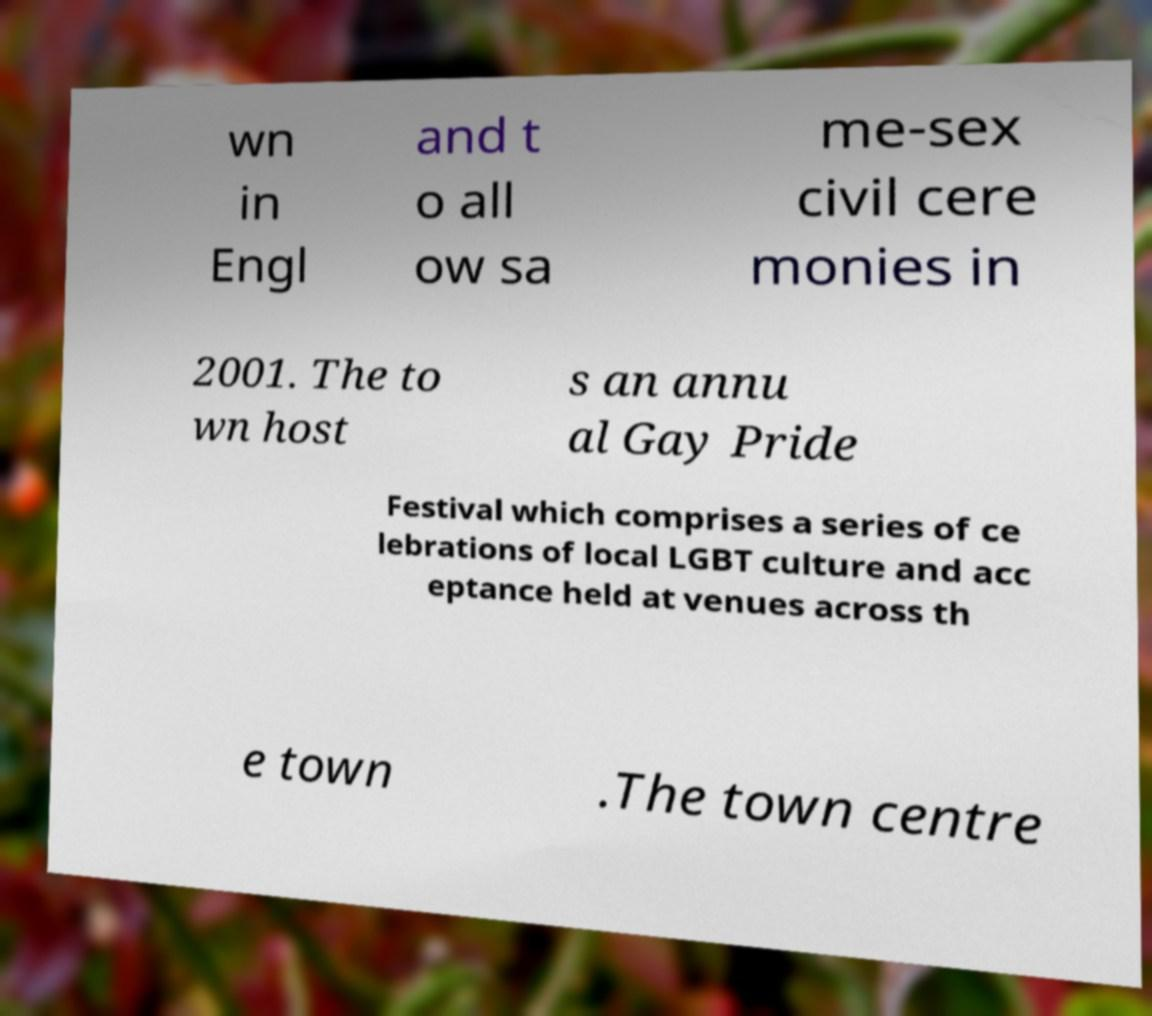For documentation purposes, I need the text within this image transcribed. Could you provide that? wn in Engl and t o all ow sa me-sex civil cere monies in 2001. The to wn host s an annu al Gay Pride Festival which comprises a series of ce lebrations of local LGBT culture and acc eptance held at venues across th e town .The town centre 